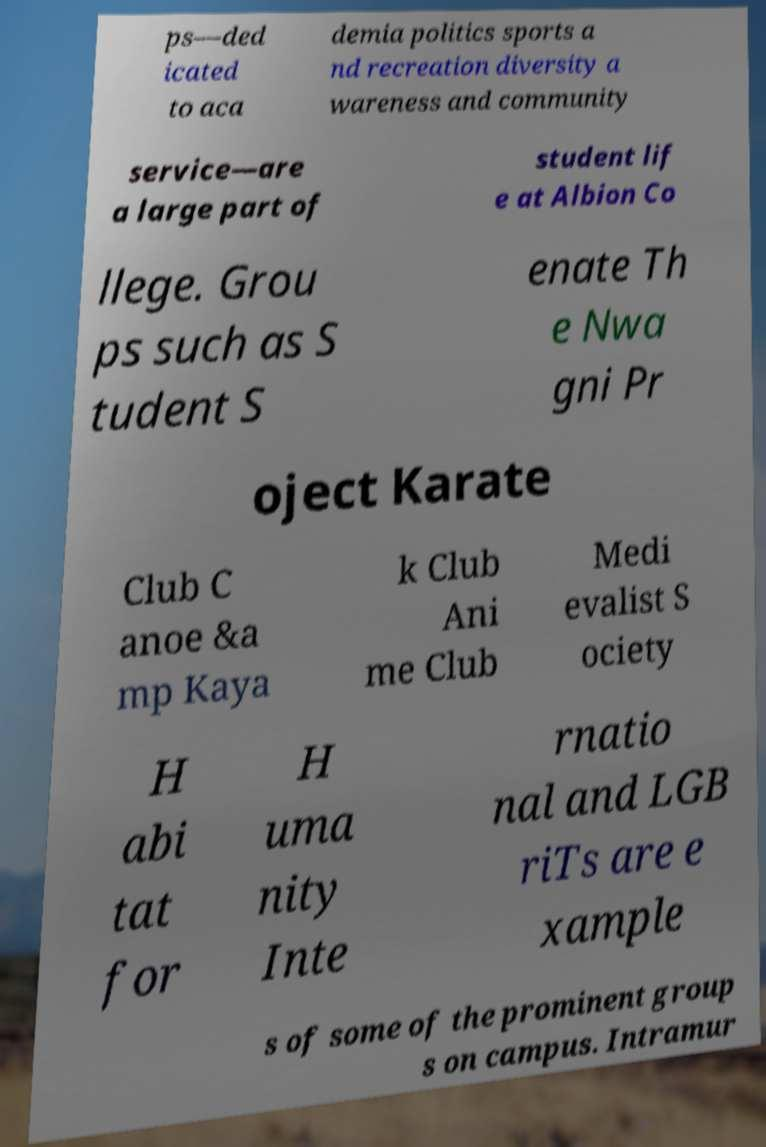Please read and relay the text visible in this image. What does it say? ps—ded icated to aca demia politics sports a nd recreation diversity a wareness and community service—are a large part of student lif e at Albion Co llege. Grou ps such as S tudent S enate Th e Nwa gni Pr oject Karate Club C anoe &a mp Kaya k Club Ani me Club Medi evalist S ociety H abi tat for H uma nity Inte rnatio nal and LGB riTs are e xample s of some of the prominent group s on campus. Intramur 